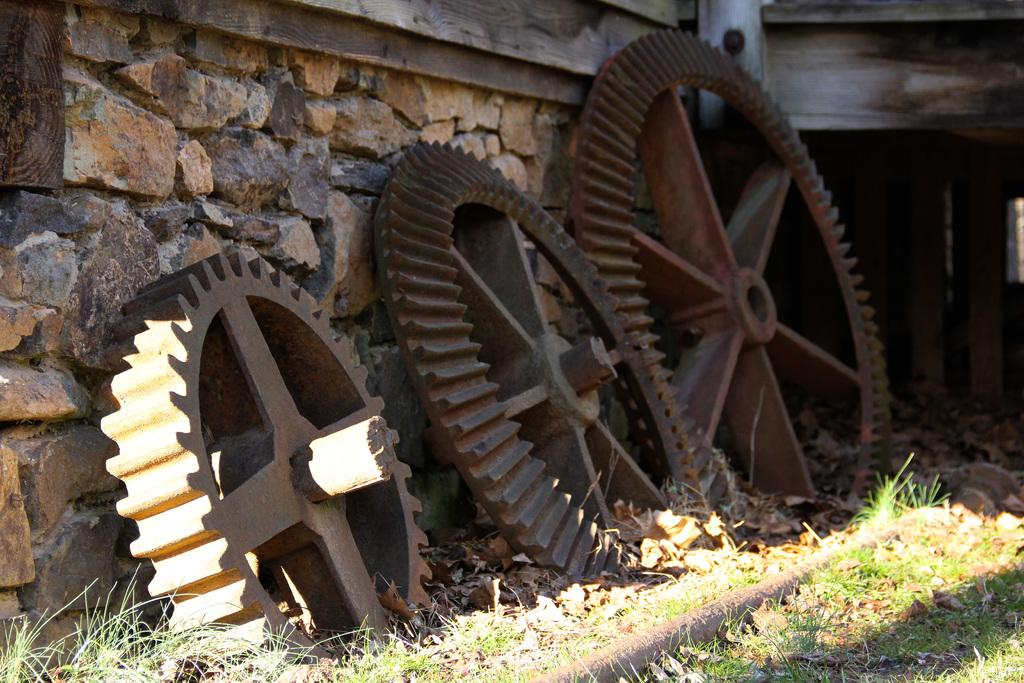What type of wheels are visible in the image? There are iron wheels in the image. What color is the grass in the image? The grass is green in the image. How would you describe the color of the wall in the background? The wall in the background is brown and cream colored. How many hairs can be seen on the iron wheels in the image? There are no hairs present on the iron wheels in the image, as they are made of metal and not a living organism. What type of calculator is visible in the image? There is no calculator present in the image. 